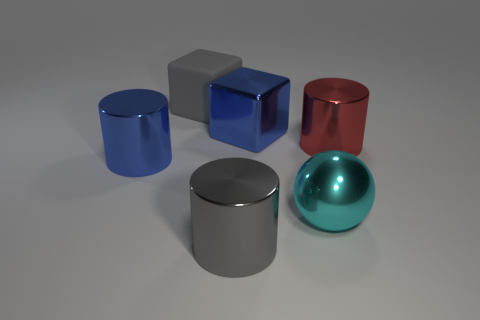What size is the object that is the same color as the metal cube?
Make the answer very short. Large. Are the large cyan ball and the gray block made of the same material?
Ensure brevity in your answer.  No. How many balls are big cyan matte objects or big red metal objects?
Provide a short and direct response. 0. Are there any other things that are the same color as the large ball?
Offer a terse response. No. There is a gray thing behind the big metallic object that is right of the large cyan object; what is it made of?
Give a very brief answer. Rubber. Do the big blue block and the gray object that is behind the red metal cylinder have the same material?
Ensure brevity in your answer.  No. What number of things are metallic things that are behind the big shiny sphere or large shiny cubes?
Ensure brevity in your answer.  3. Are there any large metal objects of the same color as the matte object?
Offer a terse response. Yes. Do the red metal object and the big blue thing that is behind the red shiny thing have the same shape?
Your answer should be compact. No. What number of shiny things are both in front of the cyan metal ball and right of the blue block?
Offer a very short reply. 0. 